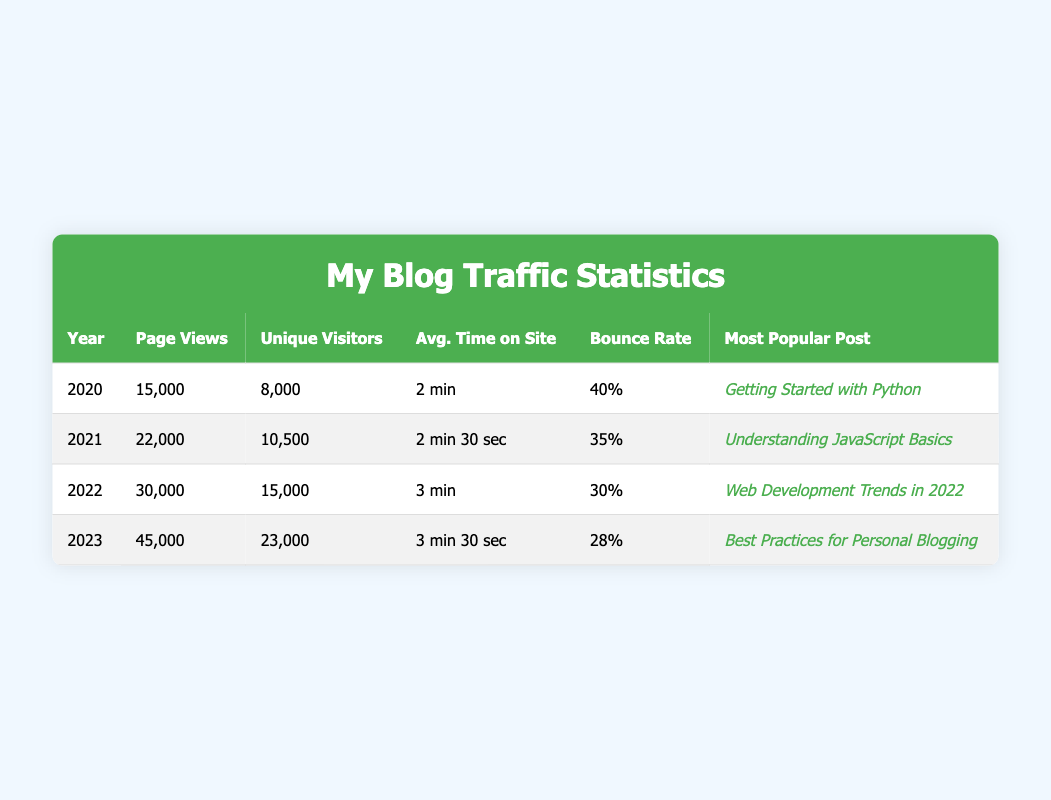what was the page view count for 2022? The table lists the data for each year. Looking at the year 2022, the page views are specifically mentioned as 30,000.
Answer: 30,000 what is the bounce rate for 2023? The bounce rate for each year is indicated in the respective row. For 2023, the bounce rate percentage is displayed as 28%.
Answer: 28% which year had the highest number of unique visitors? Comparing the unique visitors across all years, 2023 shows the highest count of unique visitors at 23,000 when we look at the table.
Answer: 2023 what is the average page views from 2020 to 2023? To find the average page views, we first sum the page views for all years: 15,000 + 22,000 + 30,000 + 45,000 = 112,000. Next, we divide by the number of years, which is 4: 112,000 / 4 = 28,000.
Answer: 28,000 was "Web Development Trends in 2022" the most popular post in 2021? The table shows that "Web Development Trends in 2022" was the most popular post in 2022, not 2021, which had "Understanding JavaScript Basics" instead. Therefore, the statement is false.
Answer: No how much did page views increase from 2021 to 2022? The page views in 2021 were 22,000 and in 2022 they were 30,000. The increase can be calculated by subtracting 2021's page views from 2022's: 30,000 - 22,000 = 8,000.
Answer: 8,000 which year saw the greatest improvement in average time on site? We need to compare the average time on site across the years: 2020 (2 min), 2021 (2 min 30 sec), 2022 (3 min), and 2023 (3 min 30 sec). The largest increase is from 2021 to 2022 (2 min 30 sec to 3 min) which is a 30 seconds improvement.
Answer: 2021 to 2022 how many unique visitors were there in 2022? By looking at the row for 2022 in the table, the unique visitors are clearly mentioned as 15,000.
Answer: 15,000 is the most popular post for 2020 related to learning programming languages? The most popular post for 2020 was "Getting Started with Python", which is focused on a programming language, thus it is true that it relates to learning programming languages.
Answer: Yes 